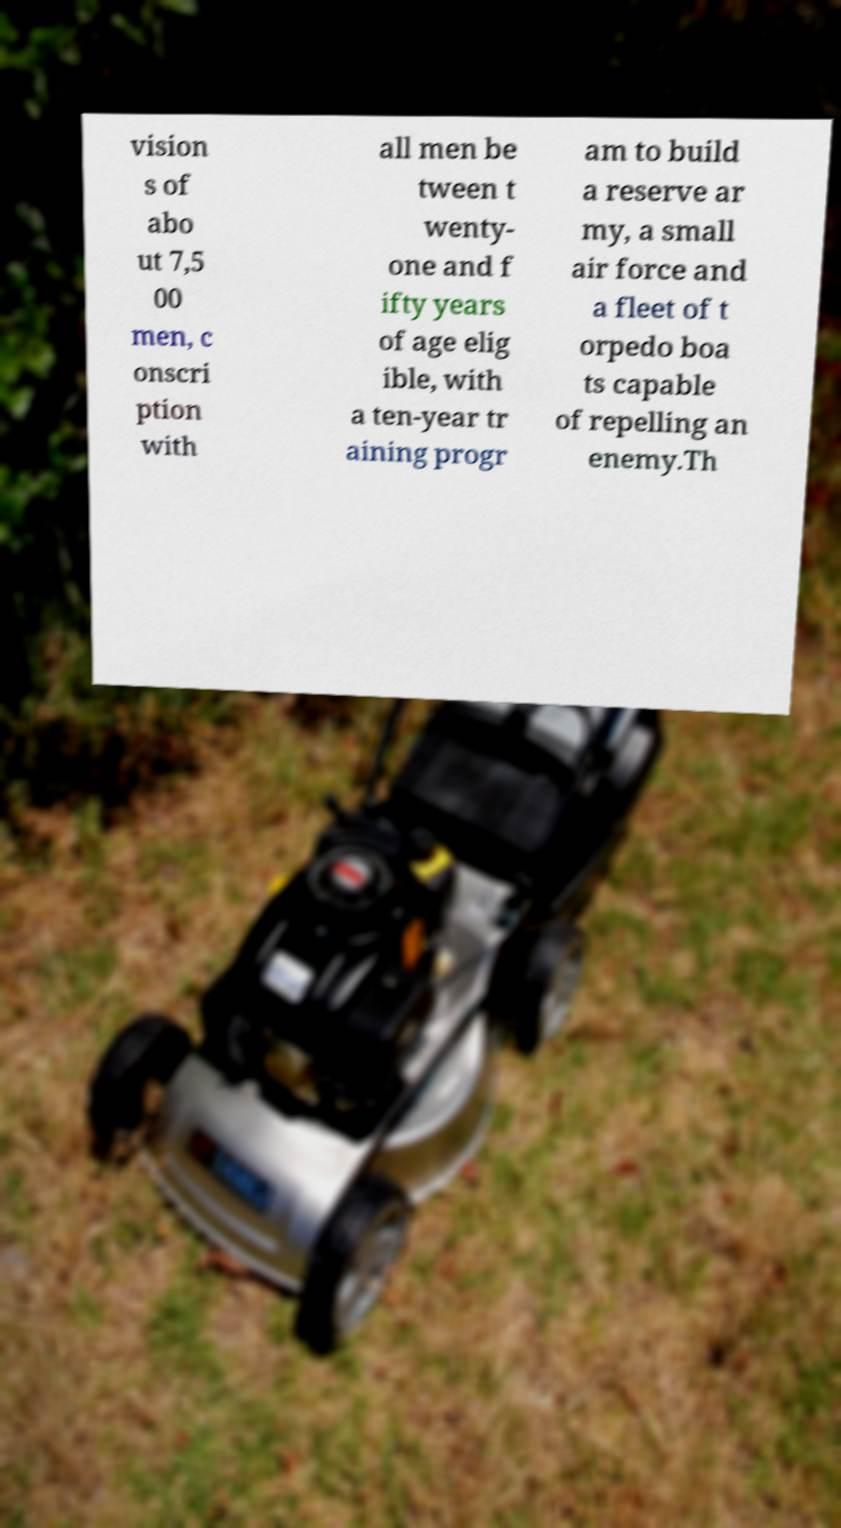There's text embedded in this image that I need extracted. Can you transcribe it verbatim? vision s of abo ut 7,5 00 men, c onscri ption with all men be tween t wenty- one and f ifty years of age elig ible, with a ten-year tr aining progr am to build a reserve ar my, a small air force and a fleet of t orpedo boa ts capable of repelling an enemy.Th 